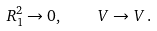Convert formula to latex. <formula><loc_0><loc_0><loc_500><loc_500>R _ { 1 } ^ { 2 } \rightarrow 0 , \quad V \rightarrow V \, .</formula> 